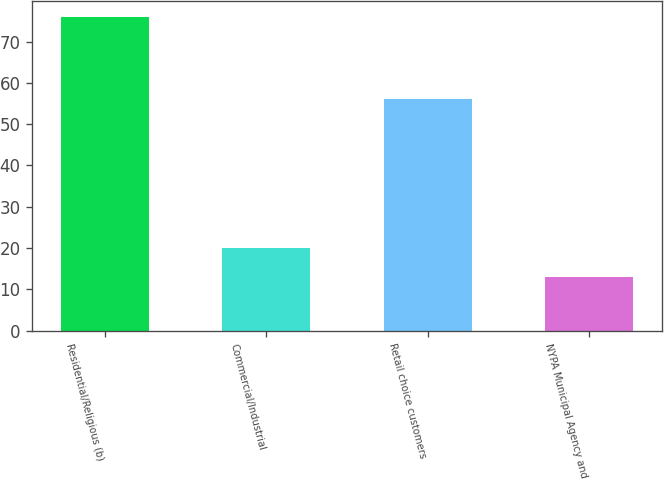<chart> <loc_0><loc_0><loc_500><loc_500><bar_chart><fcel>Residential/Religious (b)<fcel>Commercial/Industrial<fcel>Retail choice customers<fcel>NYPA Municipal Agency and<nl><fcel>76<fcel>20<fcel>56<fcel>13<nl></chart> 